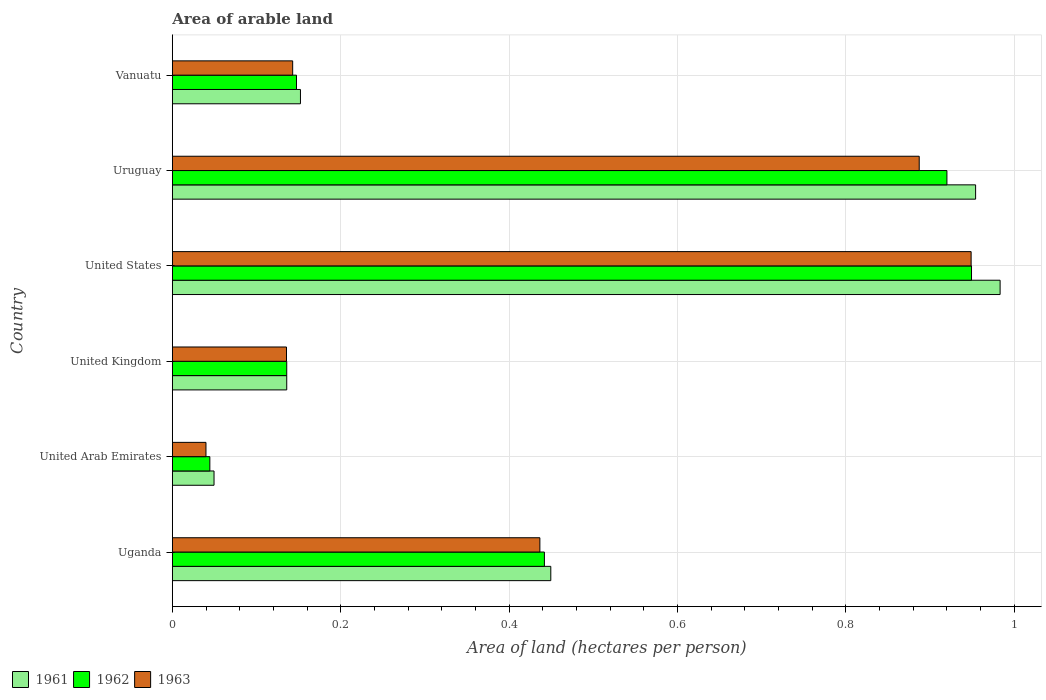How many groups of bars are there?
Provide a succinct answer. 6. Are the number of bars per tick equal to the number of legend labels?
Provide a succinct answer. Yes. Are the number of bars on each tick of the Y-axis equal?
Provide a short and direct response. Yes. How many bars are there on the 2nd tick from the top?
Keep it short and to the point. 3. How many bars are there on the 4th tick from the bottom?
Your answer should be compact. 3. What is the label of the 4th group of bars from the top?
Keep it short and to the point. United Kingdom. In how many cases, is the number of bars for a given country not equal to the number of legend labels?
Your answer should be compact. 0. What is the total arable land in 1961 in Uruguay?
Give a very brief answer. 0.95. Across all countries, what is the maximum total arable land in 1961?
Make the answer very short. 0.98. Across all countries, what is the minimum total arable land in 1963?
Your answer should be compact. 0.04. In which country was the total arable land in 1962 minimum?
Ensure brevity in your answer.  United Arab Emirates. What is the total total arable land in 1961 in the graph?
Ensure brevity in your answer.  2.72. What is the difference between the total arable land in 1961 in United States and that in Vanuatu?
Ensure brevity in your answer.  0.83. What is the difference between the total arable land in 1963 in Uruguay and the total arable land in 1962 in Vanuatu?
Give a very brief answer. 0.74. What is the average total arable land in 1962 per country?
Your response must be concise. 0.44. What is the difference between the total arable land in 1961 and total arable land in 1963 in Uganda?
Keep it short and to the point. 0.01. In how many countries, is the total arable land in 1962 greater than 0.6400000000000001 hectares per person?
Offer a very short reply. 2. What is the ratio of the total arable land in 1962 in Uruguay to that in Vanuatu?
Your answer should be compact. 6.24. Is the difference between the total arable land in 1961 in United Arab Emirates and Vanuatu greater than the difference between the total arable land in 1963 in United Arab Emirates and Vanuatu?
Offer a very short reply. Yes. What is the difference between the highest and the second highest total arable land in 1961?
Provide a short and direct response. 0.03. What is the difference between the highest and the lowest total arable land in 1961?
Keep it short and to the point. 0.93. In how many countries, is the total arable land in 1963 greater than the average total arable land in 1963 taken over all countries?
Offer a terse response. 3. Is the sum of the total arable land in 1962 in United Kingdom and United States greater than the maximum total arable land in 1961 across all countries?
Give a very brief answer. Yes. What is the difference between two consecutive major ticks on the X-axis?
Ensure brevity in your answer.  0.2. Are the values on the major ticks of X-axis written in scientific E-notation?
Provide a short and direct response. No. Does the graph contain any zero values?
Make the answer very short. No. Does the graph contain grids?
Offer a terse response. Yes. Where does the legend appear in the graph?
Your answer should be very brief. Bottom left. What is the title of the graph?
Provide a succinct answer. Area of arable land. Does "1987" appear as one of the legend labels in the graph?
Offer a very short reply. No. What is the label or title of the X-axis?
Your answer should be compact. Area of land (hectares per person). What is the label or title of the Y-axis?
Provide a succinct answer. Country. What is the Area of land (hectares per person) in 1961 in Uganda?
Make the answer very short. 0.45. What is the Area of land (hectares per person) of 1962 in Uganda?
Offer a very short reply. 0.44. What is the Area of land (hectares per person) of 1963 in Uganda?
Ensure brevity in your answer.  0.44. What is the Area of land (hectares per person) in 1961 in United Arab Emirates?
Ensure brevity in your answer.  0.05. What is the Area of land (hectares per person) in 1962 in United Arab Emirates?
Give a very brief answer. 0.04. What is the Area of land (hectares per person) in 1963 in United Arab Emirates?
Provide a succinct answer. 0.04. What is the Area of land (hectares per person) of 1961 in United Kingdom?
Ensure brevity in your answer.  0.14. What is the Area of land (hectares per person) of 1962 in United Kingdom?
Your answer should be compact. 0.14. What is the Area of land (hectares per person) in 1963 in United Kingdom?
Keep it short and to the point. 0.14. What is the Area of land (hectares per person) of 1961 in United States?
Make the answer very short. 0.98. What is the Area of land (hectares per person) in 1962 in United States?
Give a very brief answer. 0.95. What is the Area of land (hectares per person) in 1963 in United States?
Give a very brief answer. 0.95. What is the Area of land (hectares per person) of 1961 in Uruguay?
Keep it short and to the point. 0.95. What is the Area of land (hectares per person) of 1962 in Uruguay?
Give a very brief answer. 0.92. What is the Area of land (hectares per person) in 1963 in Uruguay?
Your response must be concise. 0.89. What is the Area of land (hectares per person) of 1961 in Vanuatu?
Ensure brevity in your answer.  0.15. What is the Area of land (hectares per person) of 1962 in Vanuatu?
Make the answer very short. 0.15. What is the Area of land (hectares per person) of 1963 in Vanuatu?
Provide a short and direct response. 0.14. Across all countries, what is the maximum Area of land (hectares per person) of 1961?
Offer a very short reply. 0.98. Across all countries, what is the maximum Area of land (hectares per person) of 1962?
Provide a short and direct response. 0.95. Across all countries, what is the maximum Area of land (hectares per person) of 1963?
Give a very brief answer. 0.95. Across all countries, what is the minimum Area of land (hectares per person) in 1961?
Make the answer very short. 0.05. Across all countries, what is the minimum Area of land (hectares per person) of 1962?
Provide a succinct answer. 0.04. Across all countries, what is the minimum Area of land (hectares per person) of 1963?
Your response must be concise. 0.04. What is the total Area of land (hectares per person) of 1961 in the graph?
Keep it short and to the point. 2.72. What is the total Area of land (hectares per person) in 1962 in the graph?
Your answer should be compact. 2.64. What is the total Area of land (hectares per person) of 1963 in the graph?
Provide a succinct answer. 2.59. What is the difference between the Area of land (hectares per person) in 1961 in Uganda and that in United Arab Emirates?
Your answer should be compact. 0.4. What is the difference between the Area of land (hectares per person) of 1962 in Uganda and that in United Arab Emirates?
Make the answer very short. 0.4. What is the difference between the Area of land (hectares per person) in 1963 in Uganda and that in United Arab Emirates?
Provide a short and direct response. 0.4. What is the difference between the Area of land (hectares per person) in 1961 in Uganda and that in United Kingdom?
Make the answer very short. 0.31. What is the difference between the Area of land (hectares per person) in 1962 in Uganda and that in United Kingdom?
Provide a succinct answer. 0.31. What is the difference between the Area of land (hectares per person) in 1963 in Uganda and that in United Kingdom?
Make the answer very short. 0.3. What is the difference between the Area of land (hectares per person) in 1961 in Uganda and that in United States?
Your answer should be very brief. -0.53. What is the difference between the Area of land (hectares per person) in 1962 in Uganda and that in United States?
Ensure brevity in your answer.  -0.51. What is the difference between the Area of land (hectares per person) of 1963 in Uganda and that in United States?
Keep it short and to the point. -0.51. What is the difference between the Area of land (hectares per person) in 1961 in Uganda and that in Uruguay?
Make the answer very short. -0.5. What is the difference between the Area of land (hectares per person) in 1962 in Uganda and that in Uruguay?
Your answer should be compact. -0.48. What is the difference between the Area of land (hectares per person) of 1963 in Uganda and that in Uruguay?
Your answer should be compact. -0.45. What is the difference between the Area of land (hectares per person) of 1961 in Uganda and that in Vanuatu?
Offer a very short reply. 0.3. What is the difference between the Area of land (hectares per person) of 1962 in Uganda and that in Vanuatu?
Your answer should be compact. 0.29. What is the difference between the Area of land (hectares per person) of 1963 in Uganda and that in Vanuatu?
Offer a terse response. 0.29. What is the difference between the Area of land (hectares per person) in 1961 in United Arab Emirates and that in United Kingdom?
Keep it short and to the point. -0.09. What is the difference between the Area of land (hectares per person) in 1962 in United Arab Emirates and that in United Kingdom?
Your answer should be compact. -0.09. What is the difference between the Area of land (hectares per person) in 1963 in United Arab Emirates and that in United Kingdom?
Your answer should be compact. -0.1. What is the difference between the Area of land (hectares per person) of 1961 in United Arab Emirates and that in United States?
Make the answer very short. -0.93. What is the difference between the Area of land (hectares per person) in 1962 in United Arab Emirates and that in United States?
Offer a terse response. -0.9. What is the difference between the Area of land (hectares per person) of 1963 in United Arab Emirates and that in United States?
Make the answer very short. -0.91. What is the difference between the Area of land (hectares per person) of 1961 in United Arab Emirates and that in Uruguay?
Your answer should be compact. -0.9. What is the difference between the Area of land (hectares per person) in 1962 in United Arab Emirates and that in Uruguay?
Your response must be concise. -0.88. What is the difference between the Area of land (hectares per person) of 1963 in United Arab Emirates and that in Uruguay?
Offer a terse response. -0.85. What is the difference between the Area of land (hectares per person) of 1961 in United Arab Emirates and that in Vanuatu?
Ensure brevity in your answer.  -0.1. What is the difference between the Area of land (hectares per person) of 1962 in United Arab Emirates and that in Vanuatu?
Make the answer very short. -0.1. What is the difference between the Area of land (hectares per person) in 1963 in United Arab Emirates and that in Vanuatu?
Offer a terse response. -0.1. What is the difference between the Area of land (hectares per person) in 1961 in United Kingdom and that in United States?
Make the answer very short. -0.85. What is the difference between the Area of land (hectares per person) in 1962 in United Kingdom and that in United States?
Give a very brief answer. -0.81. What is the difference between the Area of land (hectares per person) in 1963 in United Kingdom and that in United States?
Keep it short and to the point. -0.81. What is the difference between the Area of land (hectares per person) of 1961 in United Kingdom and that in Uruguay?
Give a very brief answer. -0.82. What is the difference between the Area of land (hectares per person) in 1962 in United Kingdom and that in Uruguay?
Your answer should be very brief. -0.78. What is the difference between the Area of land (hectares per person) of 1963 in United Kingdom and that in Uruguay?
Give a very brief answer. -0.75. What is the difference between the Area of land (hectares per person) of 1961 in United Kingdom and that in Vanuatu?
Provide a succinct answer. -0.02. What is the difference between the Area of land (hectares per person) in 1962 in United Kingdom and that in Vanuatu?
Keep it short and to the point. -0.01. What is the difference between the Area of land (hectares per person) in 1963 in United Kingdom and that in Vanuatu?
Offer a very short reply. -0.01. What is the difference between the Area of land (hectares per person) in 1961 in United States and that in Uruguay?
Make the answer very short. 0.03. What is the difference between the Area of land (hectares per person) in 1962 in United States and that in Uruguay?
Offer a terse response. 0.03. What is the difference between the Area of land (hectares per person) of 1963 in United States and that in Uruguay?
Your answer should be compact. 0.06. What is the difference between the Area of land (hectares per person) of 1961 in United States and that in Vanuatu?
Make the answer very short. 0.83. What is the difference between the Area of land (hectares per person) in 1962 in United States and that in Vanuatu?
Offer a very short reply. 0.8. What is the difference between the Area of land (hectares per person) in 1963 in United States and that in Vanuatu?
Give a very brief answer. 0.81. What is the difference between the Area of land (hectares per person) of 1961 in Uruguay and that in Vanuatu?
Give a very brief answer. 0.8. What is the difference between the Area of land (hectares per person) of 1962 in Uruguay and that in Vanuatu?
Give a very brief answer. 0.77. What is the difference between the Area of land (hectares per person) in 1963 in Uruguay and that in Vanuatu?
Give a very brief answer. 0.74. What is the difference between the Area of land (hectares per person) in 1961 in Uganda and the Area of land (hectares per person) in 1962 in United Arab Emirates?
Your answer should be compact. 0.41. What is the difference between the Area of land (hectares per person) in 1961 in Uganda and the Area of land (hectares per person) in 1963 in United Arab Emirates?
Your answer should be very brief. 0.41. What is the difference between the Area of land (hectares per person) of 1962 in Uganda and the Area of land (hectares per person) of 1963 in United Arab Emirates?
Ensure brevity in your answer.  0.4. What is the difference between the Area of land (hectares per person) of 1961 in Uganda and the Area of land (hectares per person) of 1962 in United Kingdom?
Your response must be concise. 0.31. What is the difference between the Area of land (hectares per person) of 1961 in Uganda and the Area of land (hectares per person) of 1963 in United Kingdom?
Your response must be concise. 0.31. What is the difference between the Area of land (hectares per person) in 1962 in Uganda and the Area of land (hectares per person) in 1963 in United Kingdom?
Make the answer very short. 0.31. What is the difference between the Area of land (hectares per person) of 1961 in Uganda and the Area of land (hectares per person) of 1962 in United States?
Give a very brief answer. -0.5. What is the difference between the Area of land (hectares per person) in 1961 in Uganda and the Area of land (hectares per person) in 1963 in United States?
Provide a short and direct response. -0.5. What is the difference between the Area of land (hectares per person) of 1962 in Uganda and the Area of land (hectares per person) of 1963 in United States?
Your answer should be very brief. -0.51. What is the difference between the Area of land (hectares per person) in 1961 in Uganda and the Area of land (hectares per person) in 1962 in Uruguay?
Give a very brief answer. -0.47. What is the difference between the Area of land (hectares per person) of 1961 in Uganda and the Area of land (hectares per person) of 1963 in Uruguay?
Your answer should be very brief. -0.44. What is the difference between the Area of land (hectares per person) of 1962 in Uganda and the Area of land (hectares per person) of 1963 in Uruguay?
Offer a very short reply. -0.45. What is the difference between the Area of land (hectares per person) in 1961 in Uganda and the Area of land (hectares per person) in 1962 in Vanuatu?
Ensure brevity in your answer.  0.3. What is the difference between the Area of land (hectares per person) in 1961 in Uganda and the Area of land (hectares per person) in 1963 in Vanuatu?
Give a very brief answer. 0.31. What is the difference between the Area of land (hectares per person) of 1962 in Uganda and the Area of land (hectares per person) of 1963 in Vanuatu?
Offer a terse response. 0.3. What is the difference between the Area of land (hectares per person) in 1961 in United Arab Emirates and the Area of land (hectares per person) in 1962 in United Kingdom?
Your answer should be very brief. -0.09. What is the difference between the Area of land (hectares per person) in 1961 in United Arab Emirates and the Area of land (hectares per person) in 1963 in United Kingdom?
Offer a very short reply. -0.09. What is the difference between the Area of land (hectares per person) in 1962 in United Arab Emirates and the Area of land (hectares per person) in 1963 in United Kingdom?
Offer a terse response. -0.09. What is the difference between the Area of land (hectares per person) in 1961 in United Arab Emirates and the Area of land (hectares per person) in 1962 in United States?
Provide a succinct answer. -0.9. What is the difference between the Area of land (hectares per person) of 1961 in United Arab Emirates and the Area of land (hectares per person) of 1963 in United States?
Offer a very short reply. -0.9. What is the difference between the Area of land (hectares per person) of 1962 in United Arab Emirates and the Area of land (hectares per person) of 1963 in United States?
Keep it short and to the point. -0.9. What is the difference between the Area of land (hectares per person) in 1961 in United Arab Emirates and the Area of land (hectares per person) in 1962 in Uruguay?
Your response must be concise. -0.87. What is the difference between the Area of land (hectares per person) in 1961 in United Arab Emirates and the Area of land (hectares per person) in 1963 in Uruguay?
Your response must be concise. -0.84. What is the difference between the Area of land (hectares per person) in 1962 in United Arab Emirates and the Area of land (hectares per person) in 1963 in Uruguay?
Give a very brief answer. -0.84. What is the difference between the Area of land (hectares per person) of 1961 in United Arab Emirates and the Area of land (hectares per person) of 1962 in Vanuatu?
Offer a terse response. -0.1. What is the difference between the Area of land (hectares per person) in 1961 in United Arab Emirates and the Area of land (hectares per person) in 1963 in Vanuatu?
Your response must be concise. -0.09. What is the difference between the Area of land (hectares per person) of 1962 in United Arab Emirates and the Area of land (hectares per person) of 1963 in Vanuatu?
Ensure brevity in your answer.  -0.1. What is the difference between the Area of land (hectares per person) of 1961 in United Kingdom and the Area of land (hectares per person) of 1962 in United States?
Give a very brief answer. -0.81. What is the difference between the Area of land (hectares per person) in 1961 in United Kingdom and the Area of land (hectares per person) in 1963 in United States?
Your answer should be very brief. -0.81. What is the difference between the Area of land (hectares per person) in 1962 in United Kingdom and the Area of land (hectares per person) in 1963 in United States?
Ensure brevity in your answer.  -0.81. What is the difference between the Area of land (hectares per person) of 1961 in United Kingdom and the Area of land (hectares per person) of 1962 in Uruguay?
Offer a terse response. -0.78. What is the difference between the Area of land (hectares per person) of 1961 in United Kingdom and the Area of land (hectares per person) of 1963 in Uruguay?
Provide a succinct answer. -0.75. What is the difference between the Area of land (hectares per person) of 1962 in United Kingdom and the Area of land (hectares per person) of 1963 in Uruguay?
Keep it short and to the point. -0.75. What is the difference between the Area of land (hectares per person) of 1961 in United Kingdom and the Area of land (hectares per person) of 1962 in Vanuatu?
Your answer should be very brief. -0.01. What is the difference between the Area of land (hectares per person) of 1961 in United Kingdom and the Area of land (hectares per person) of 1963 in Vanuatu?
Your response must be concise. -0.01. What is the difference between the Area of land (hectares per person) in 1962 in United Kingdom and the Area of land (hectares per person) in 1963 in Vanuatu?
Offer a very short reply. -0.01. What is the difference between the Area of land (hectares per person) in 1961 in United States and the Area of land (hectares per person) in 1962 in Uruguay?
Ensure brevity in your answer.  0.06. What is the difference between the Area of land (hectares per person) in 1961 in United States and the Area of land (hectares per person) in 1963 in Uruguay?
Offer a terse response. 0.1. What is the difference between the Area of land (hectares per person) in 1962 in United States and the Area of land (hectares per person) in 1963 in Uruguay?
Provide a short and direct response. 0.06. What is the difference between the Area of land (hectares per person) in 1961 in United States and the Area of land (hectares per person) in 1962 in Vanuatu?
Offer a terse response. 0.84. What is the difference between the Area of land (hectares per person) in 1961 in United States and the Area of land (hectares per person) in 1963 in Vanuatu?
Offer a terse response. 0.84. What is the difference between the Area of land (hectares per person) of 1962 in United States and the Area of land (hectares per person) of 1963 in Vanuatu?
Make the answer very short. 0.81. What is the difference between the Area of land (hectares per person) of 1961 in Uruguay and the Area of land (hectares per person) of 1962 in Vanuatu?
Your answer should be very brief. 0.81. What is the difference between the Area of land (hectares per person) in 1961 in Uruguay and the Area of land (hectares per person) in 1963 in Vanuatu?
Your answer should be compact. 0.81. What is the difference between the Area of land (hectares per person) of 1962 in Uruguay and the Area of land (hectares per person) of 1963 in Vanuatu?
Offer a very short reply. 0.78. What is the average Area of land (hectares per person) of 1961 per country?
Provide a short and direct response. 0.45. What is the average Area of land (hectares per person) of 1962 per country?
Your answer should be very brief. 0.44. What is the average Area of land (hectares per person) in 1963 per country?
Ensure brevity in your answer.  0.43. What is the difference between the Area of land (hectares per person) in 1961 and Area of land (hectares per person) in 1962 in Uganda?
Ensure brevity in your answer.  0.01. What is the difference between the Area of land (hectares per person) in 1961 and Area of land (hectares per person) in 1963 in Uganda?
Your answer should be very brief. 0.01. What is the difference between the Area of land (hectares per person) in 1962 and Area of land (hectares per person) in 1963 in Uganda?
Offer a terse response. 0.01. What is the difference between the Area of land (hectares per person) in 1961 and Area of land (hectares per person) in 1962 in United Arab Emirates?
Give a very brief answer. 0.01. What is the difference between the Area of land (hectares per person) of 1961 and Area of land (hectares per person) of 1963 in United Arab Emirates?
Offer a very short reply. 0.01. What is the difference between the Area of land (hectares per person) in 1962 and Area of land (hectares per person) in 1963 in United Arab Emirates?
Give a very brief answer. 0. What is the difference between the Area of land (hectares per person) in 1961 and Area of land (hectares per person) in 1962 in United States?
Provide a succinct answer. 0.03. What is the difference between the Area of land (hectares per person) in 1961 and Area of land (hectares per person) in 1963 in United States?
Offer a terse response. 0.03. What is the difference between the Area of land (hectares per person) in 1962 and Area of land (hectares per person) in 1963 in United States?
Provide a short and direct response. 0. What is the difference between the Area of land (hectares per person) of 1961 and Area of land (hectares per person) of 1962 in Uruguay?
Give a very brief answer. 0.03. What is the difference between the Area of land (hectares per person) of 1961 and Area of land (hectares per person) of 1963 in Uruguay?
Provide a succinct answer. 0.07. What is the difference between the Area of land (hectares per person) in 1962 and Area of land (hectares per person) in 1963 in Uruguay?
Offer a very short reply. 0.03. What is the difference between the Area of land (hectares per person) of 1961 and Area of land (hectares per person) of 1962 in Vanuatu?
Provide a succinct answer. 0. What is the difference between the Area of land (hectares per person) of 1961 and Area of land (hectares per person) of 1963 in Vanuatu?
Provide a succinct answer. 0.01. What is the difference between the Area of land (hectares per person) in 1962 and Area of land (hectares per person) in 1963 in Vanuatu?
Offer a very short reply. 0. What is the ratio of the Area of land (hectares per person) in 1961 in Uganda to that in United Arab Emirates?
Offer a very short reply. 9.08. What is the ratio of the Area of land (hectares per person) of 1962 in Uganda to that in United Arab Emirates?
Your answer should be compact. 9.92. What is the ratio of the Area of land (hectares per person) in 1963 in Uganda to that in United Arab Emirates?
Your response must be concise. 10.93. What is the ratio of the Area of land (hectares per person) of 1961 in Uganda to that in United Kingdom?
Offer a terse response. 3.31. What is the ratio of the Area of land (hectares per person) of 1962 in Uganda to that in United Kingdom?
Offer a terse response. 3.25. What is the ratio of the Area of land (hectares per person) of 1963 in Uganda to that in United Kingdom?
Provide a succinct answer. 3.22. What is the ratio of the Area of land (hectares per person) in 1961 in Uganda to that in United States?
Your answer should be compact. 0.46. What is the ratio of the Area of land (hectares per person) of 1962 in Uganda to that in United States?
Provide a succinct answer. 0.47. What is the ratio of the Area of land (hectares per person) of 1963 in Uganda to that in United States?
Provide a short and direct response. 0.46. What is the ratio of the Area of land (hectares per person) in 1961 in Uganda to that in Uruguay?
Give a very brief answer. 0.47. What is the ratio of the Area of land (hectares per person) of 1962 in Uganda to that in Uruguay?
Provide a short and direct response. 0.48. What is the ratio of the Area of land (hectares per person) in 1963 in Uganda to that in Uruguay?
Make the answer very short. 0.49. What is the ratio of the Area of land (hectares per person) of 1961 in Uganda to that in Vanuatu?
Keep it short and to the point. 2.95. What is the ratio of the Area of land (hectares per person) in 1962 in Uganda to that in Vanuatu?
Give a very brief answer. 3. What is the ratio of the Area of land (hectares per person) in 1963 in Uganda to that in Vanuatu?
Your response must be concise. 3.05. What is the ratio of the Area of land (hectares per person) in 1961 in United Arab Emirates to that in United Kingdom?
Keep it short and to the point. 0.36. What is the ratio of the Area of land (hectares per person) of 1962 in United Arab Emirates to that in United Kingdom?
Offer a very short reply. 0.33. What is the ratio of the Area of land (hectares per person) of 1963 in United Arab Emirates to that in United Kingdom?
Keep it short and to the point. 0.29. What is the ratio of the Area of land (hectares per person) in 1961 in United Arab Emirates to that in United States?
Your response must be concise. 0.05. What is the ratio of the Area of land (hectares per person) in 1962 in United Arab Emirates to that in United States?
Keep it short and to the point. 0.05. What is the ratio of the Area of land (hectares per person) in 1963 in United Arab Emirates to that in United States?
Keep it short and to the point. 0.04. What is the ratio of the Area of land (hectares per person) of 1961 in United Arab Emirates to that in Uruguay?
Your answer should be compact. 0.05. What is the ratio of the Area of land (hectares per person) of 1962 in United Arab Emirates to that in Uruguay?
Offer a terse response. 0.05. What is the ratio of the Area of land (hectares per person) of 1963 in United Arab Emirates to that in Uruguay?
Offer a very short reply. 0.04. What is the ratio of the Area of land (hectares per person) of 1961 in United Arab Emirates to that in Vanuatu?
Keep it short and to the point. 0.33. What is the ratio of the Area of land (hectares per person) of 1962 in United Arab Emirates to that in Vanuatu?
Keep it short and to the point. 0.3. What is the ratio of the Area of land (hectares per person) of 1963 in United Arab Emirates to that in Vanuatu?
Your response must be concise. 0.28. What is the ratio of the Area of land (hectares per person) in 1961 in United Kingdom to that in United States?
Provide a succinct answer. 0.14. What is the ratio of the Area of land (hectares per person) in 1962 in United Kingdom to that in United States?
Provide a succinct answer. 0.14. What is the ratio of the Area of land (hectares per person) of 1963 in United Kingdom to that in United States?
Your answer should be compact. 0.14. What is the ratio of the Area of land (hectares per person) in 1961 in United Kingdom to that in Uruguay?
Give a very brief answer. 0.14. What is the ratio of the Area of land (hectares per person) of 1962 in United Kingdom to that in Uruguay?
Offer a very short reply. 0.15. What is the ratio of the Area of land (hectares per person) of 1963 in United Kingdom to that in Uruguay?
Offer a terse response. 0.15. What is the ratio of the Area of land (hectares per person) in 1961 in United Kingdom to that in Vanuatu?
Keep it short and to the point. 0.89. What is the ratio of the Area of land (hectares per person) in 1962 in United Kingdom to that in Vanuatu?
Offer a very short reply. 0.92. What is the ratio of the Area of land (hectares per person) of 1963 in United Kingdom to that in Vanuatu?
Make the answer very short. 0.95. What is the ratio of the Area of land (hectares per person) of 1961 in United States to that in Uruguay?
Your answer should be compact. 1.03. What is the ratio of the Area of land (hectares per person) in 1962 in United States to that in Uruguay?
Provide a short and direct response. 1.03. What is the ratio of the Area of land (hectares per person) in 1963 in United States to that in Uruguay?
Offer a terse response. 1.07. What is the ratio of the Area of land (hectares per person) in 1961 in United States to that in Vanuatu?
Offer a terse response. 6.46. What is the ratio of the Area of land (hectares per person) of 1962 in United States to that in Vanuatu?
Offer a very short reply. 6.44. What is the ratio of the Area of land (hectares per person) in 1963 in United States to that in Vanuatu?
Give a very brief answer. 6.64. What is the ratio of the Area of land (hectares per person) of 1961 in Uruguay to that in Vanuatu?
Provide a short and direct response. 6.27. What is the ratio of the Area of land (hectares per person) in 1962 in Uruguay to that in Vanuatu?
Your answer should be very brief. 6.24. What is the ratio of the Area of land (hectares per person) of 1963 in Uruguay to that in Vanuatu?
Your response must be concise. 6.21. What is the difference between the highest and the second highest Area of land (hectares per person) of 1961?
Keep it short and to the point. 0.03. What is the difference between the highest and the second highest Area of land (hectares per person) in 1962?
Ensure brevity in your answer.  0.03. What is the difference between the highest and the second highest Area of land (hectares per person) of 1963?
Make the answer very short. 0.06. What is the difference between the highest and the lowest Area of land (hectares per person) in 1961?
Your response must be concise. 0.93. What is the difference between the highest and the lowest Area of land (hectares per person) in 1962?
Keep it short and to the point. 0.9. What is the difference between the highest and the lowest Area of land (hectares per person) in 1963?
Offer a terse response. 0.91. 